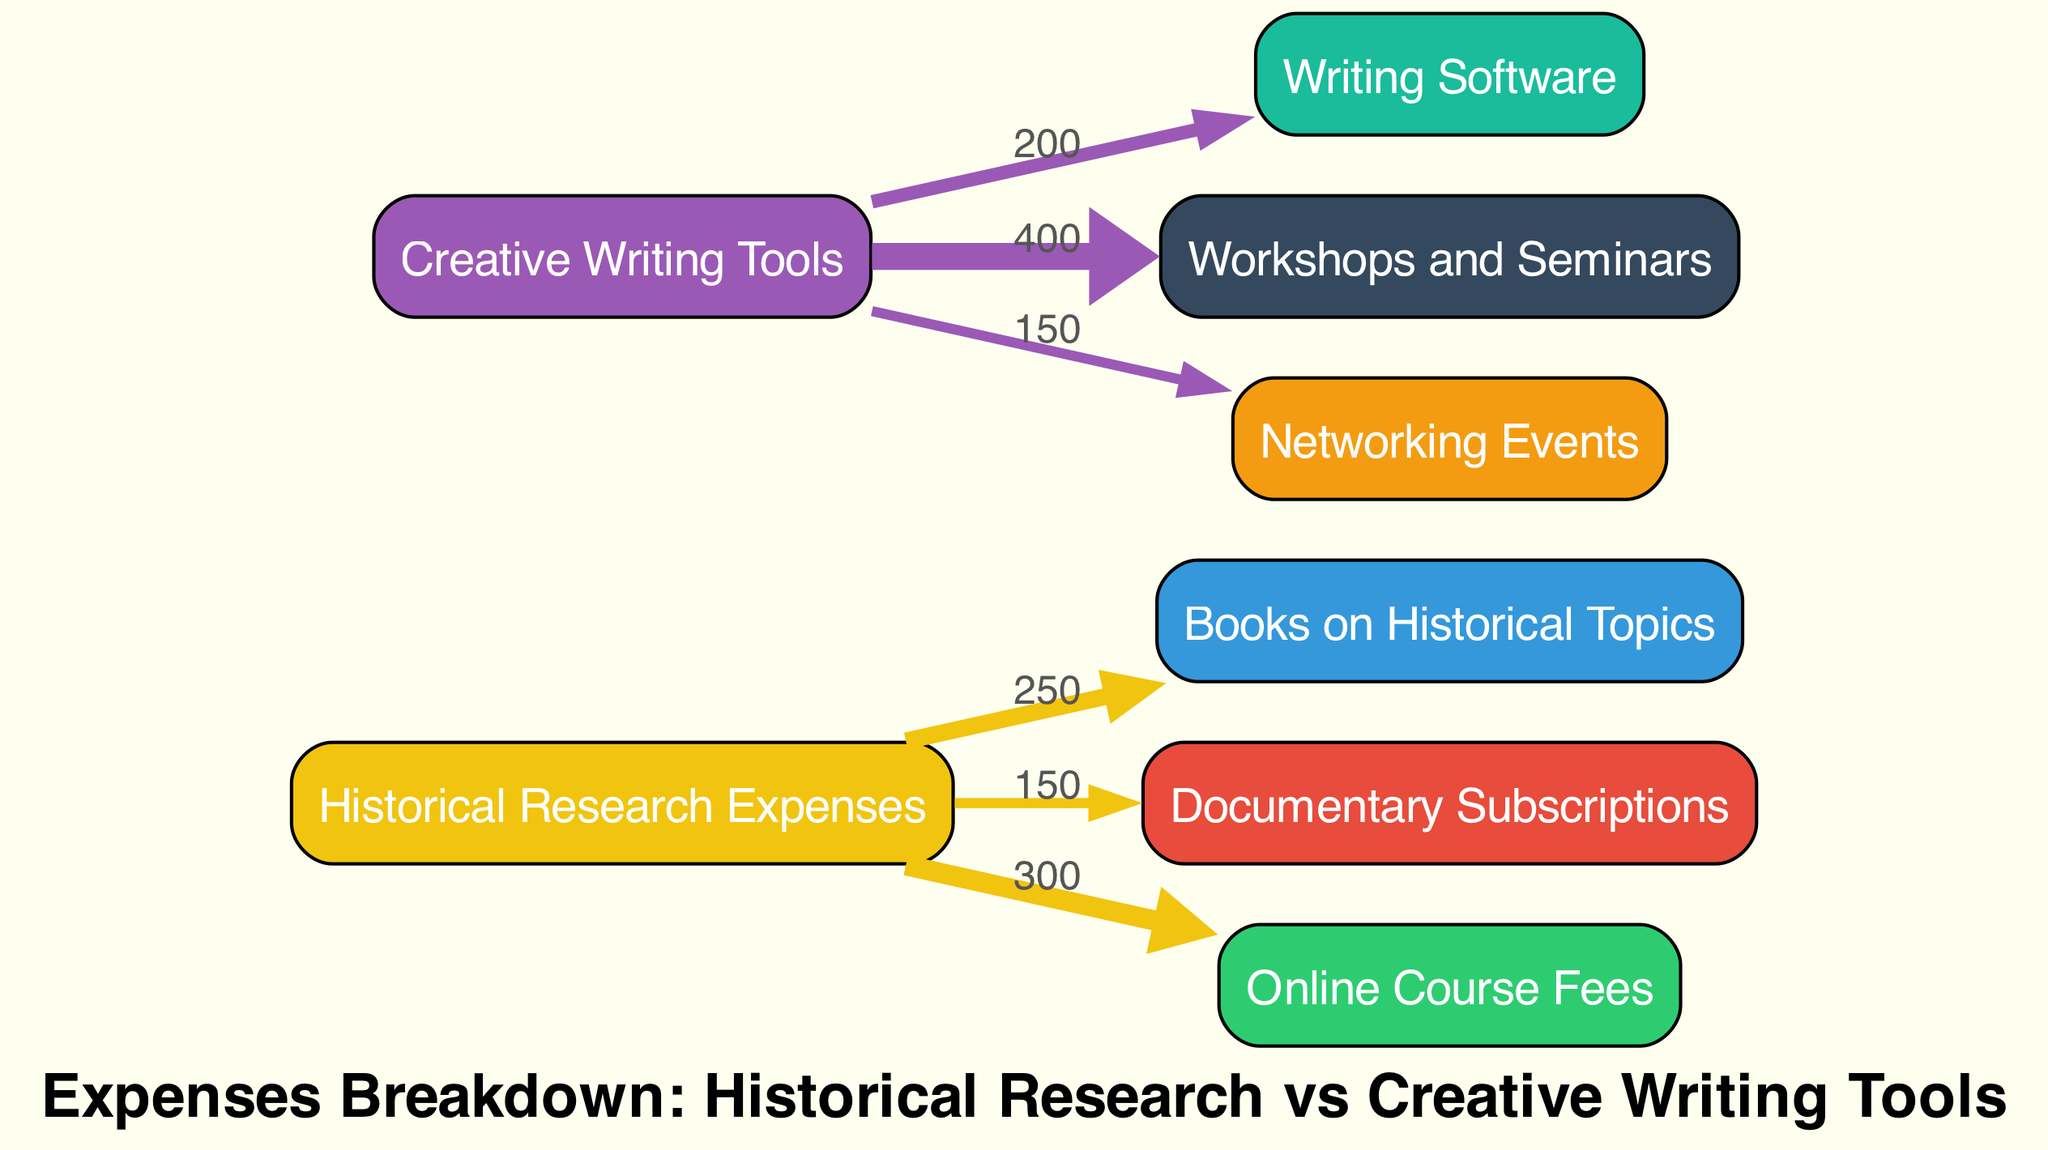What is the total expenditure on Historical Research Expenses? The total expenditure on Historical Research Expenses is the sum of the values directed towards the nodes related to historical research: Books on Historical Topics (250), Documentary Subscriptions (150), and Online Course Fees (300). So, we calculate: 250 + 150 + 300 = 700.
Answer: 700 Which category has a higher total expenditure, Historical Research Expenses or Creative Writing Tools? To find the higher category, we sum the expenses for each: Historical Research (700) includes Books (250), Documentaries (150), and Online Courses (300). For Creative Writing Tools (750), it includes Writing Software (200), Workshops (400), and Networking Events (150). Since 750 > 700, Creative Writing Tools has higher total expenditure.
Answer: Creative Writing Tools How much is spent on Documentary Subscriptions? The value for Documentary Subscriptions is directly stated in the diagram as 150.
Answer: 150 What percentage of total expenses is allocated to Books on Historical Topics? Total expenses amount to Historical Research (700) + Creative Writing Tools (750) = 1450. The expense for Books on Historical Topics is 250. To find the percentage: (250 / 1450) * 100 = 17.24%.
Answer: 17.24% Which expense category has the largest single expenditure? By evaluating all individual expenses from each category, the highest value is found in Workshops and Seminars under Creative Writing Tools, totaling 400.
Answer: Workshops and Seminars How many nodes are present in the diagram? There are 8 distinct nodes shown in the diagram: 4 under Historical Research Expenses and 4 under Creative Writing Tools.
Answer: 8 What is the flow value from Creative Writing Tools to Networking Events? The flow value from Creative Writing Tools to Networking Events is directly indicated in the diagram as 150.
Answer: 150 What is the relationship value between Historical Research Expenses and Online Course Fees? The relationship value between Historical Research Expenses and Online Course Fees is explicitly given in the diagram as 300.
Answer: 300 Which expense category shows the least expenditure? By comparing all values, we see that Documentary Subscriptions under Historical Research Expenses has the lowest expenditure of 150.
Answer: Documentary Subscriptions 